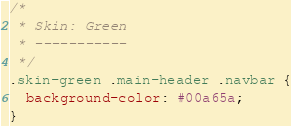Convert code to text. <code><loc_0><loc_0><loc_500><loc_500><_CSS_>/*
 * Skin: Green
 * -----------
 */
.skin-green .main-header .navbar {
  background-color: #00a65a;
}</code> 